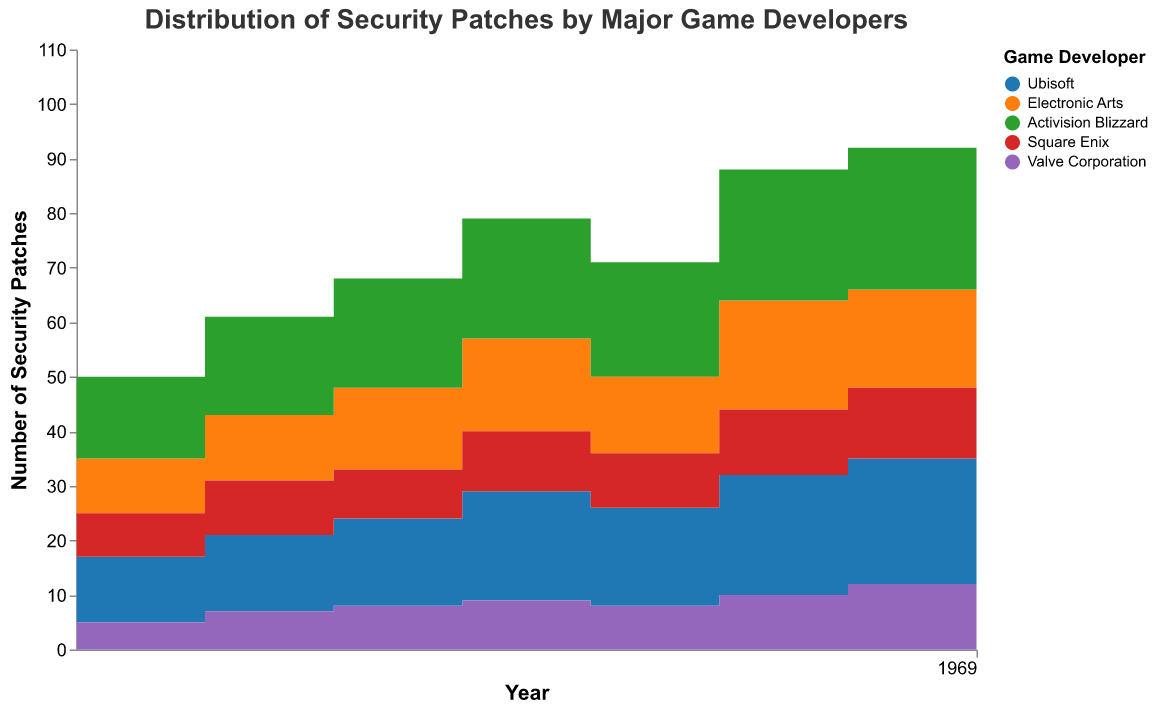What is the title of the figure? The title of the figure is presented at the top and clearly states the subject of the chart.
Answer: Distribution of Security Patches by Major Game Developers Which year did Ubisoft release the highest number of security patches? By examining the vertical rise in the step area corresponding to Ubisoft's color, the highest number of security patches is in 2022.
Answer: 2022 How many security patches did Valve Corporation release in 2020? Look at the height of Valve Corporation's section (typically purple) for the year 2020.
Answer: 10 Which game developer released the least number of patches in 2015? Compare the initial step heights of all developers in 2015. Valve Corporation's section is the smallest.
Answer: Valve Corporation What is the total number of security patches released by all developers in 2018? Sum the number of patches for each developer in 2018. Ubisoft (20), Electronic Arts (17), Activision Blizzard (22), Square Enix (11), Valve Corporation (9). Total is 20 + 17 + 22 + 11 + 9 = 79.
Answer: 79 Between 2019 and 2020, which developer saw the largest increase in patches released? Calculate the difference in the height of the step area for each developer:
Ubisoft: 22 - 18 = 4,
Electronic Arts: 20 - 14 = 6,
Activision Blizzard: 24 - 21 = 3,
Square Enix: 12 - 10 = 2,
Valve Corporation: 10 - 8 = 2.
Electronic Arts had the largest increase.
Answer: Electronic Arts In which year did Square Enix release more patches than Ubisoft? Inspect the years and check the height of each developer’s area. In none of the years did Square Enix release more patches than Ubisoft.
Answer: None What is the average number of patches released by Electronic Arts from 2015 to 2022? Sum the number of patches over the years and divide by the number of years.
(10 + 12 + 15 + 17 + 14 + 20 + 18 + 21) / 8 = 127 / 8 = 15.875.
Answer: 15.875 How many more patches did Activision Blizzard release compared to Square Enix in 2022? Subtract the number of patches released by Square Enix from those released by Activision Blizzard in 2022. 28 - 14 = 14.
Answer: 14 Did Ubisoft ever release exactly 18 patches in any year? Check the vertical change for Ubisoft from year to year. 18 patches were released in 2019.
Answer: Yes 